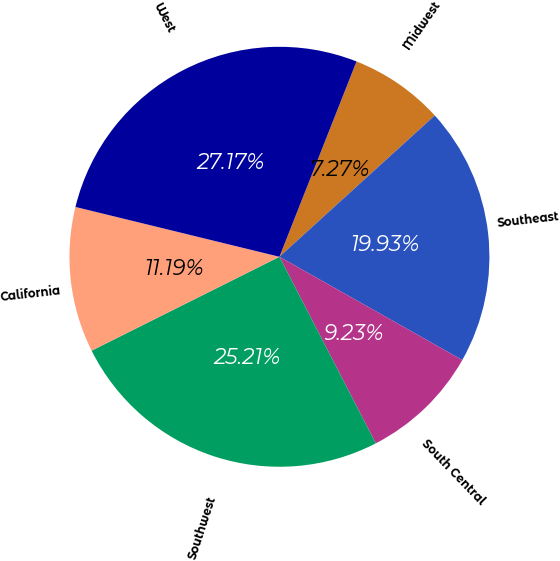<chart> <loc_0><loc_0><loc_500><loc_500><pie_chart><fcel>Midwest<fcel>Southeast<fcel>South Central<fcel>Southwest<fcel>California<fcel>West<nl><fcel>7.27%<fcel>19.93%<fcel>9.23%<fcel>25.21%<fcel>11.19%<fcel>27.17%<nl></chart> 